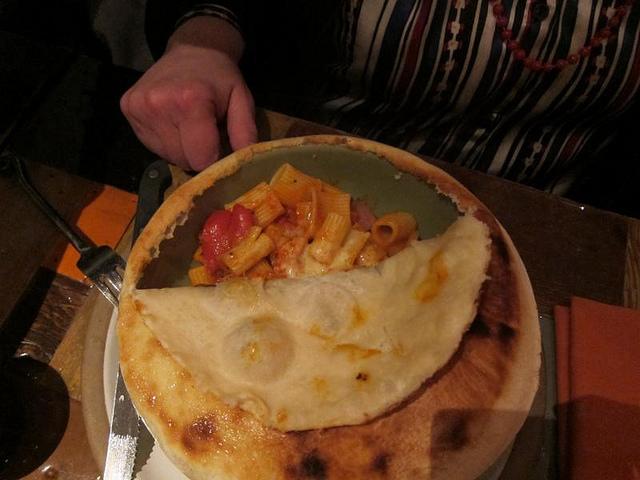Can we have a bite of the food?
Be succinct. No. Does this person have a rubber band around their wrist?
Answer briefly. No. What suggests that this meal was at least partially cooked in an oven?
Concise answer only. It's pie. What breakfast item does this resemble?
Write a very short answer. Omelet. What eating utensils are visible?
Be succinct. Fork and knife. What is between the food and the pan?
Keep it brief. Plate. Which hand is being used to hold the plate?
Concise answer only. Right. 